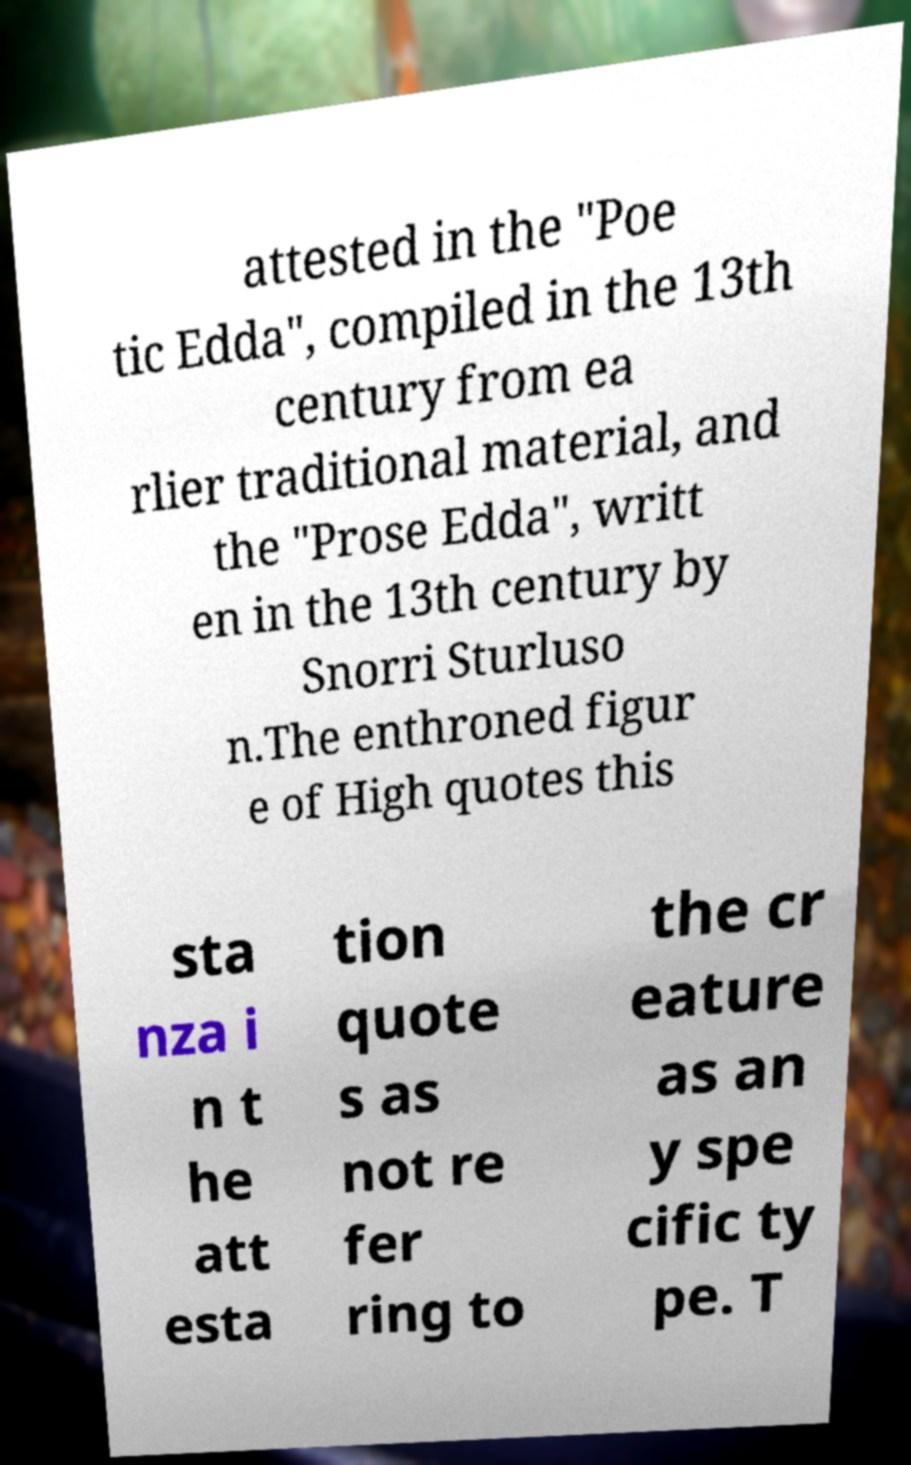Can you read and provide the text displayed in the image?This photo seems to have some interesting text. Can you extract and type it out for me? attested in the "Poe tic Edda", compiled in the 13th century from ea rlier traditional material, and the "Prose Edda", writt en in the 13th century by Snorri Sturluso n.The enthroned figur e of High quotes this sta nza i n t he att esta tion quote s as not re fer ring to the cr eature as an y spe cific ty pe. T 